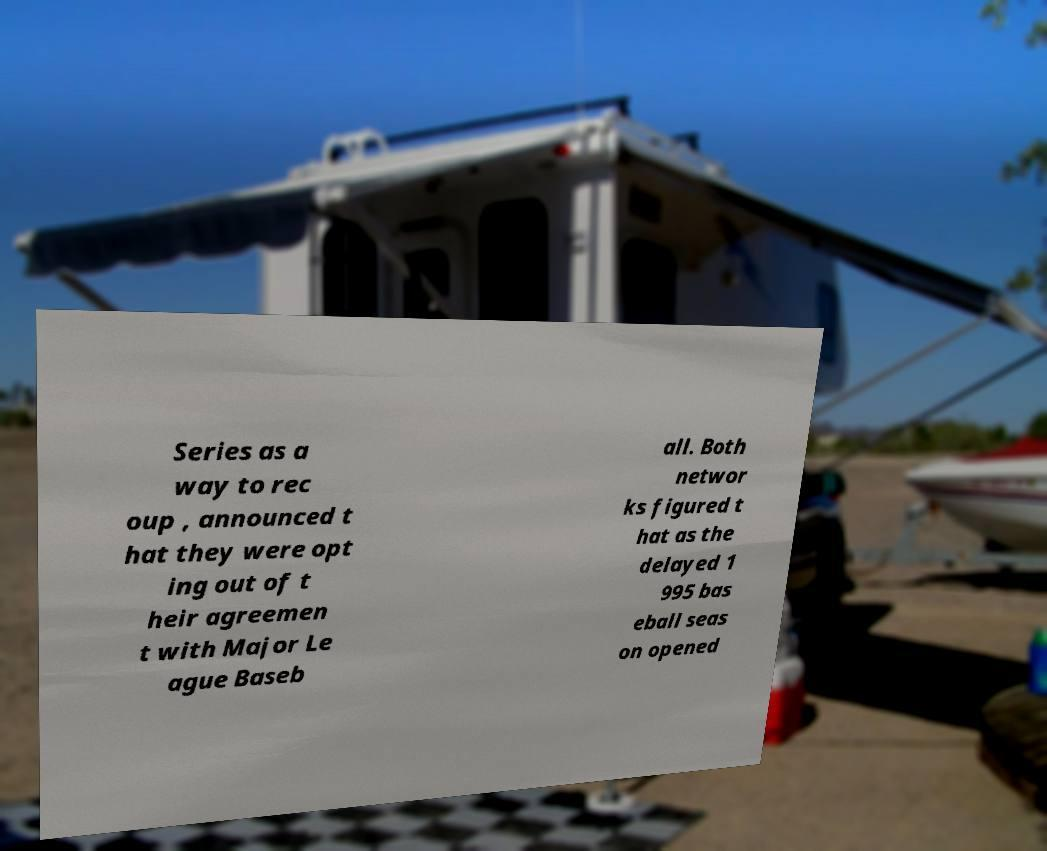I need the written content from this picture converted into text. Can you do that? Series as a way to rec oup , announced t hat they were opt ing out of t heir agreemen t with Major Le ague Baseb all. Both networ ks figured t hat as the delayed 1 995 bas eball seas on opened 